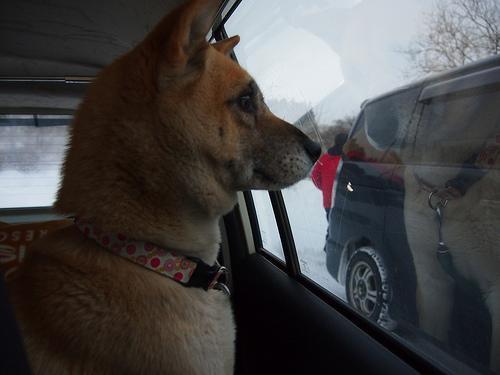How many dogs are there?
Give a very brief answer. 1. 